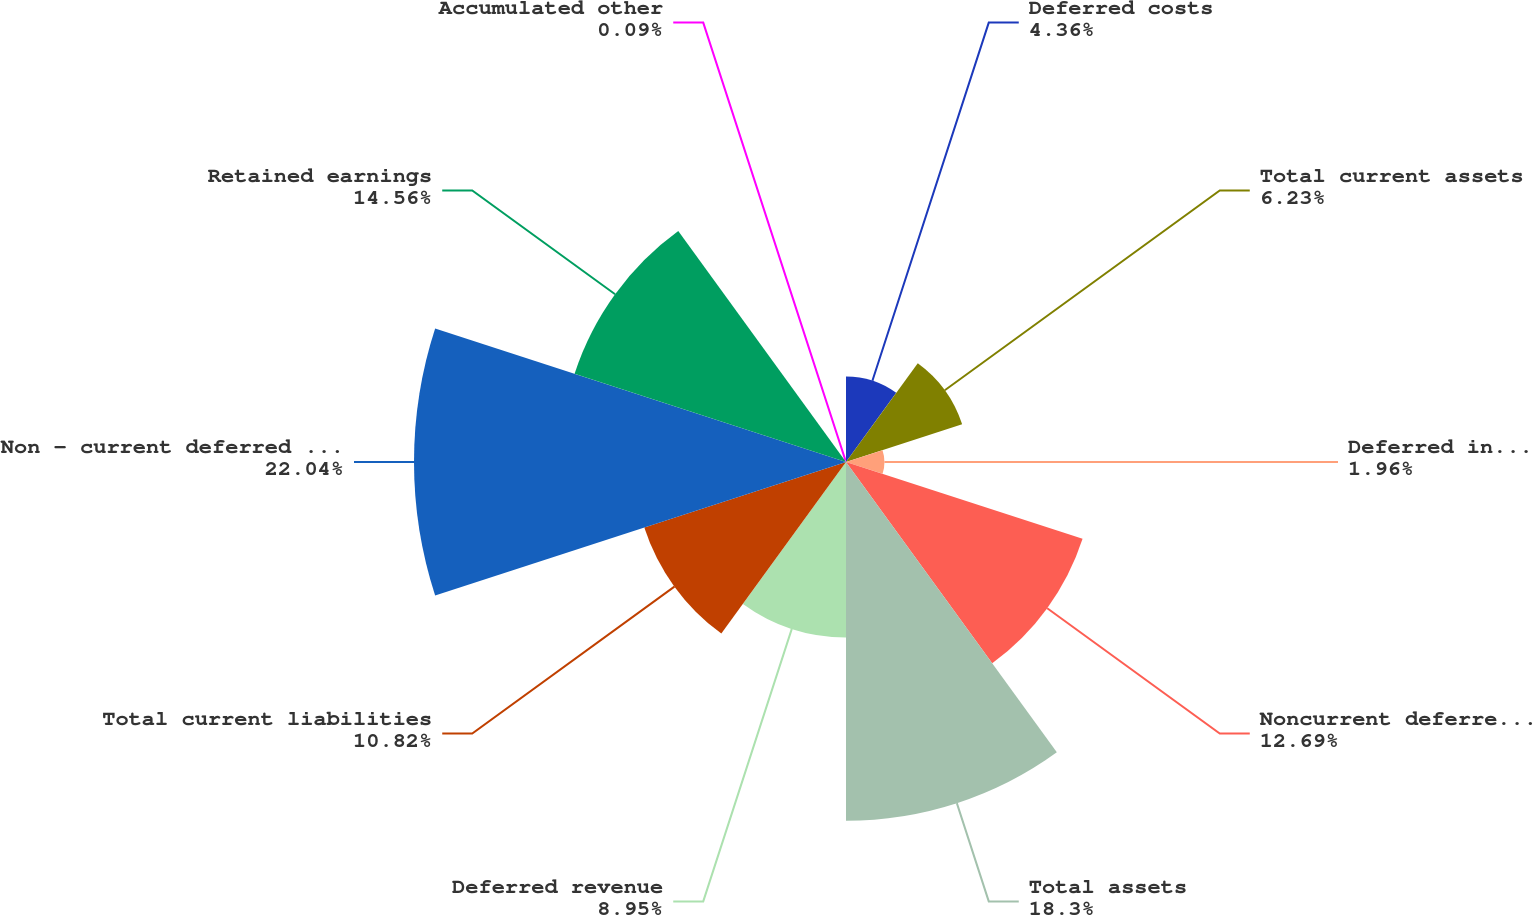Convert chart. <chart><loc_0><loc_0><loc_500><loc_500><pie_chart><fcel>Deferred costs<fcel>Total current assets<fcel>Deferred income taxes<fcel>Noncurrent deferred costs<fcel>Total assets<fcel>Deferred revenue<fcel>Total current liabilities<fcel>Non - current deferred revenue<fcel>Retained earnings<fcel>Accumulated other<nl><fcel>4.36%<fcel>6.23%<fcel>1.96%<fcel>12.69%<fcel>18.3%<fcel>8.95%<fcel>10.82%<fcel>22.04%<fcel>14.56%<fcel>0.09%<nl></chart> 